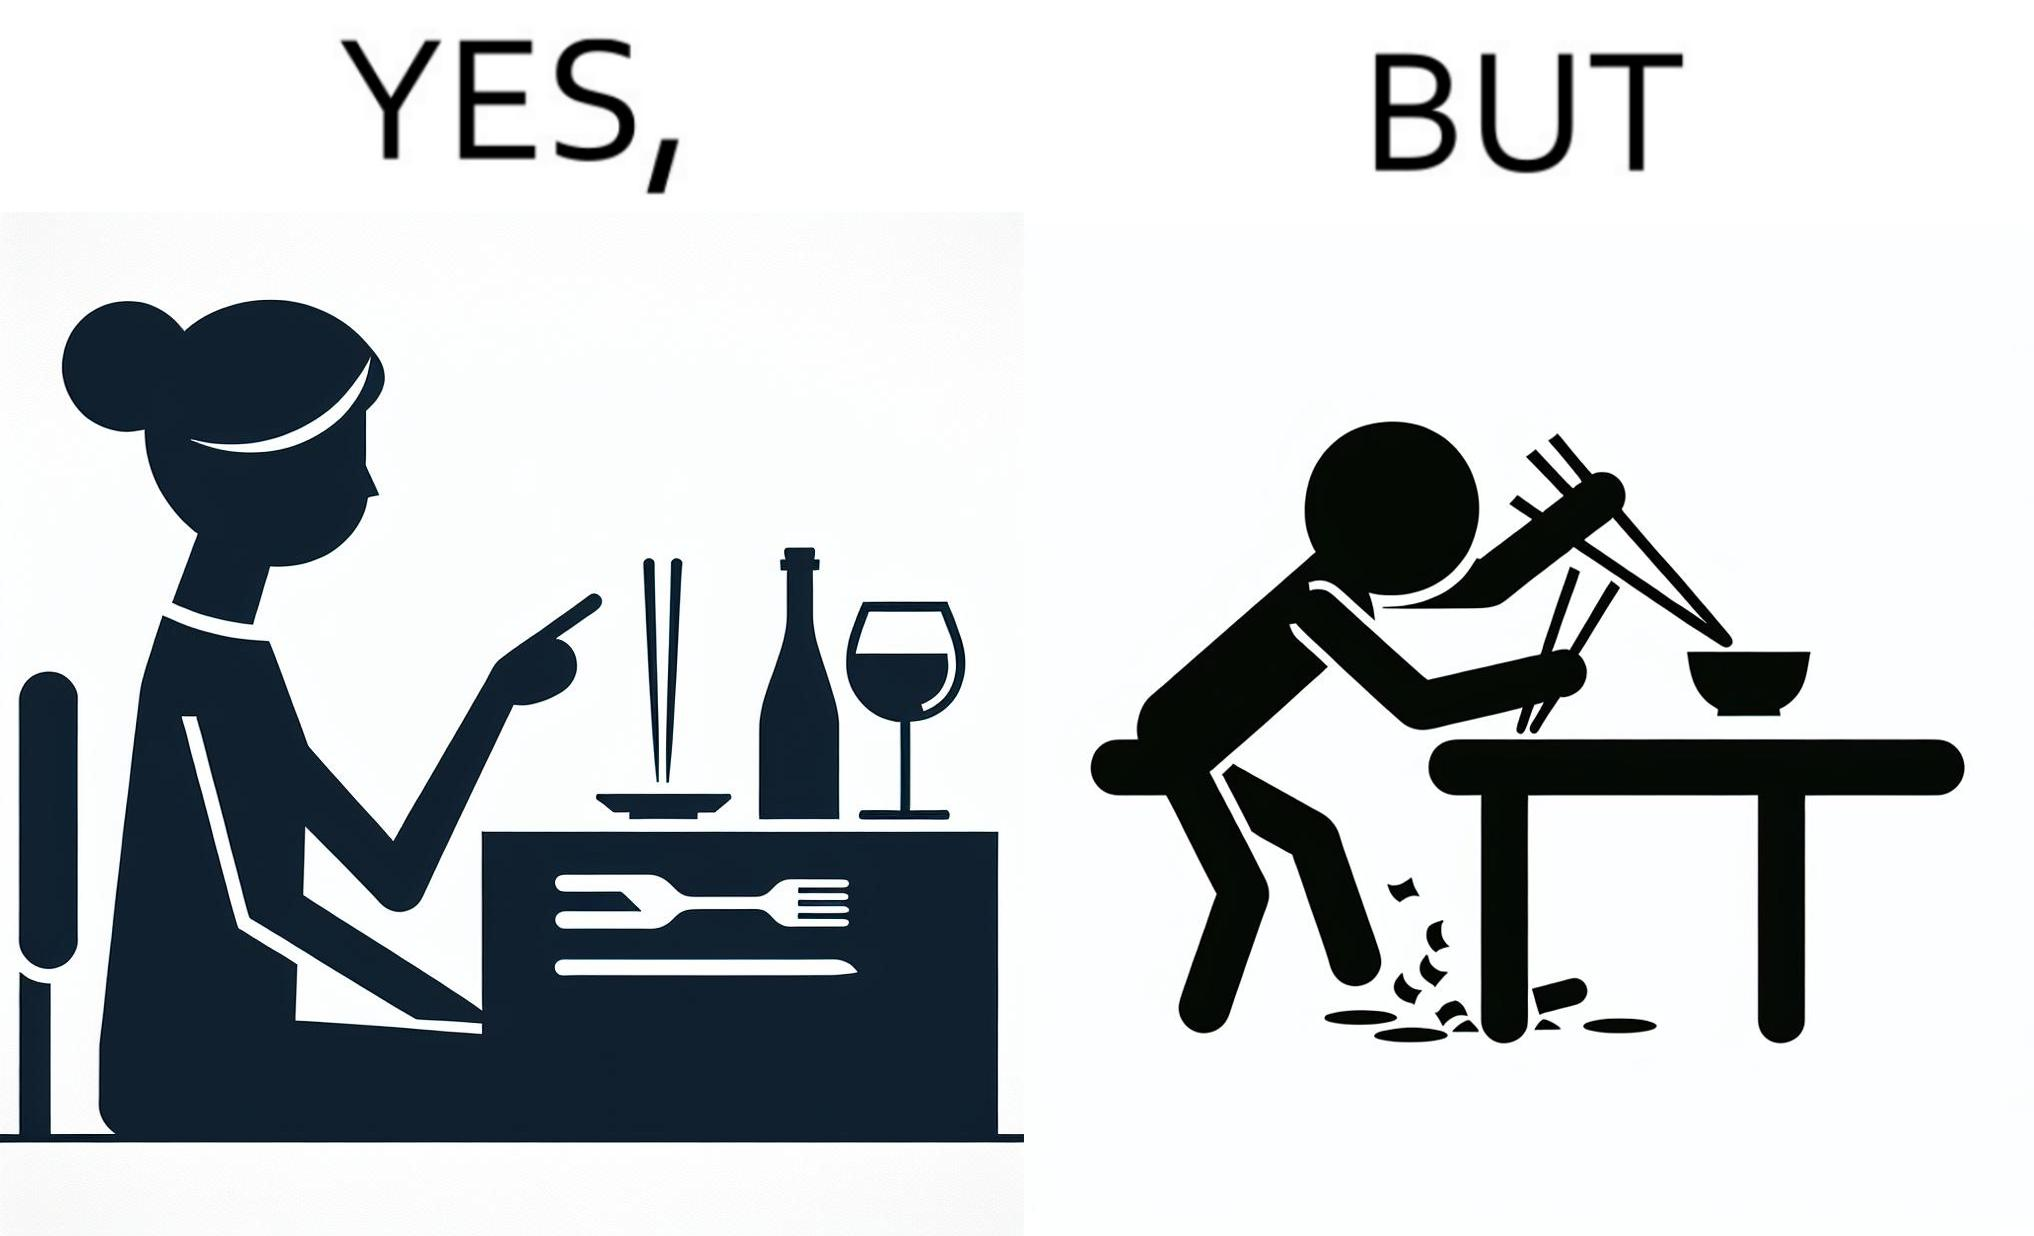Is there satirical content in this image? Yes, this image is satirical. 